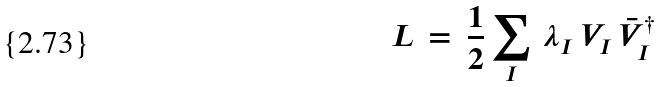Convert formula to latex. <formula><loc_0><loc_0><loc_500><loc_500>L \, = \, \frac { 1 } { 2 } \sum _ { I } \, \lambda _ { I } \, V _ { I } \, \bar { V } _ { I } ^ { \dagger }</formula> 